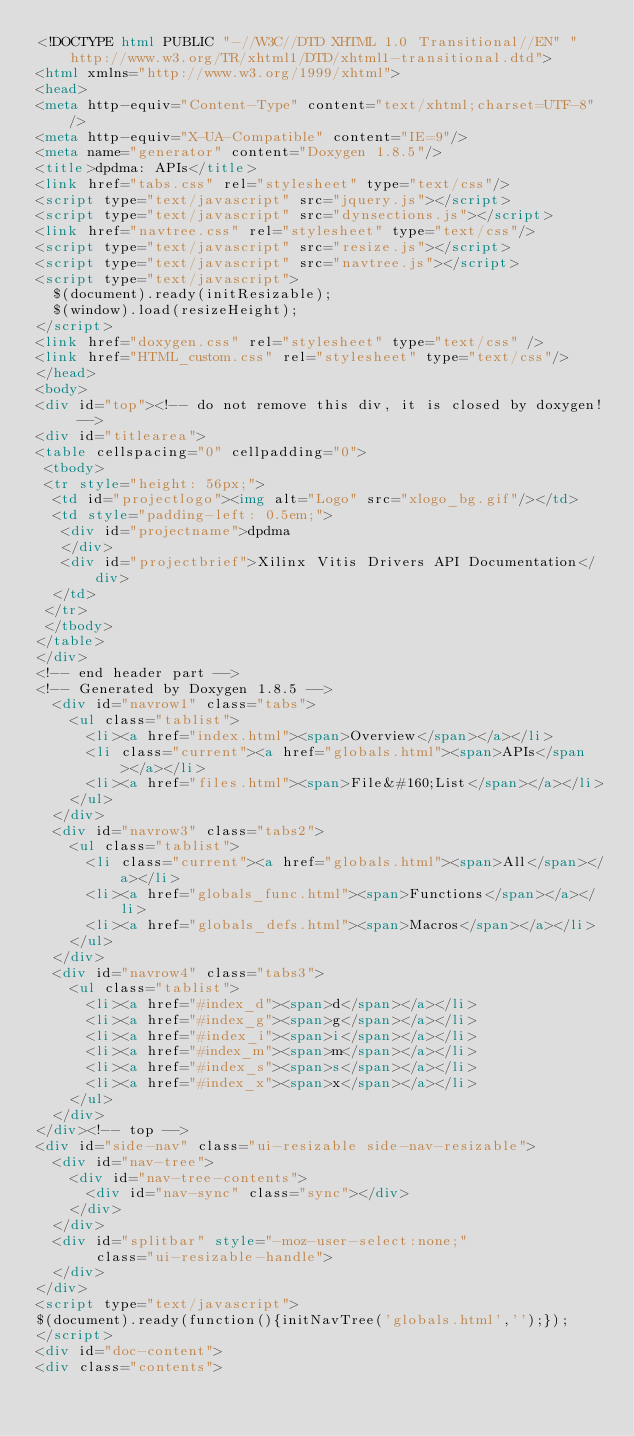<code> <loc_0><loc_0><loc_500><loc_500><_HTML_><!DOCTYPE html PUBLIC "-//W3C//DTD XHTML 1.0 Transitional//EN" "http://www.w3.org/TR/xhtml1/DTD/xhtml1-transitional.dtd">
<html xmlns="http://www.w3.org/1999/xhtml">
<head>
<meta http-equiv="Content-Type" content="text/xhtml;charset=UTF-8"/>
<meta http-equiv="X-UA-Compatible" content="IE=9"/>
<meta name="generator" content="Doxygen 1.8.5"/>
<title>dpdma: APIs</title>
<link href="tabs.css" rel="stylesheet" type="text/css"/>
<script type="text/javascript" src="jquery.js"></script>
<script type="text/javascript" src="dynsections.js"></script>
<link href="navtree.css" rel="stylesheet" type="text/css"/>
<script type="text/javascript" src="resize.js"></script>
<script type="text/javascript" src="navtree.js"></script>
<script type="text/javascript">
  $(document).ready(initResizable);
  $(window).load(resizeHeight);
</script>
<link href="doxygen.css" rel="stylesheet" type="text/css" />
<link href="HTML_custom.css" rel="stylesheet" type="text/css"/>
</head>
<body>
<div id="top"><!-- do not remove this div, it is closed by doxygen! -->
<div id="titlearea">
<table cellspacing="0" cellpadding="0">
 <tbody>
 <tr style="height: 56px;">
  <td id="projectlogo"><img alt="Logo" src="xlogo_bg.gif"/></td>
  <td style="padding-left: 0.5em;">
   <div id="projectname">dpdma
   </div>
   <div id="projectbrief">Xilinx Vitis Drivers API Documentation</div>
  </td>
 </tr>
 </tbody>
</table>
</div>
<!-- end header part -->
<!-- Generated by Doxygen 1.8.5 -->
  <div id="navrow1" class="tabs">
    <ul class="tablist">
      <li><a href="index.html"><span>Overview</span></a></li>
      <li class="current"><a href="globals.html"><span>APIs</span></a></li>
      <li><a href="files.html"><span>File&#160;List</span></a></li>
    </ul>
  </div>
  <div id="navrow3" class="tabs2">
    <ul class="tablist">
      <li class="current"><a href="globals.html"><span>All</span></a></li>
      <li><a href="globals_func.html"><span>Functions</span></a></li>
      <li><a href="globals_defs.html"><span>Macros</span></a></li>
    </ul>
  </div>
  <div id="navrow4" class="tabs3">
    <ul class="tablist">
      <li><a href="#index_d"><span>d</span></a></li>
      <li><a href="#index_g"><span>g</span></a></li>
      <li><a href="#index_i"><span>i</span></a></li>
      <li><a href="#index_m"><span>m</span></a></li>
      <li><a href="#index_s"><span>s</span></a></li>
      <li><a href="#index_x"><span>x</span></a></li>
    </ul>
  </div>
</div><!-- top -->
<div id="side-nav" class="ui-resizable side-nav-resizable">
  <div id="nav-tree">
    <div id="nav-tree-contents">
      <div id="nav-sync" class="sync"></div>
    </div>
  </div>
  <div id="splitbar" style="-moz-user-select:none;" 
       class="ui-resizable-handle">
  </div>
</div>
<script type="text/javascript">
$(document).ready(function(){initNavTree('globals.html','');});
</script>
<div id="doc-content">
<div class="contents"></code> 